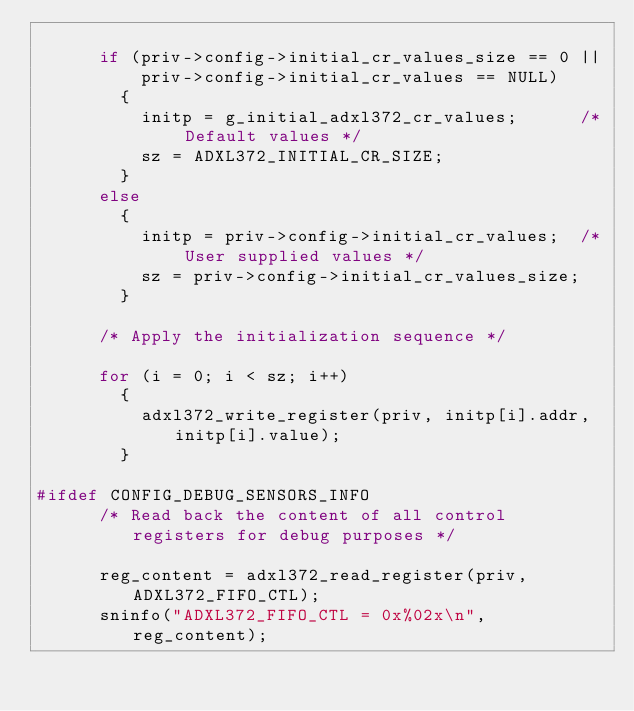Convert code to text. <code><loc_0><loc_0><loc_500><loc_500><_C_>
      if (priv->config->initial_cr_values_size == 0 ||
          priv->config->initial_cr_values == NULL)
        {
          initp = g_initial_adxl372_cr_values;      /* Default values */
          sz = ADXL372_INITIAL_CR_SIZE;
        }
      else
        {
          initp = priv->config->initial_cr_values;  /* User supplied values */
          sz = priv->config->initial_cr_values_size;
        }

      /* Apply the initialization sequence */

      for (i = 0; i < sz; i++)
        {
          adxl372_write_register(priv, initp[i].addr, initp[i].value);
        }

#ifdef CONFIG_DEBUG_SENSORS_INFO
      /* Read back the content of all control registers for debug purposes */

      reg_content = adxl372_read_register(priv, ADXL372_FIFO_CTL);
      sninfo("ADXL372_FIFO_CTL = 0x%02x\n", reg_content);
</code> 